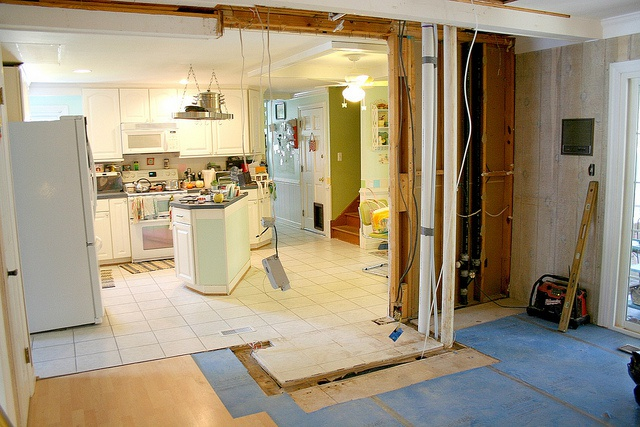Describe the objects in this image and their specific colors. I can see refrigerator in maroon, darkgray, tan, and gray tones, oven in maroon, tan, and ivory tones, oven in maroon and tan tones, microwave in maroon, beige, and tan tones, and microwave in maroon and tan tones in this image. 